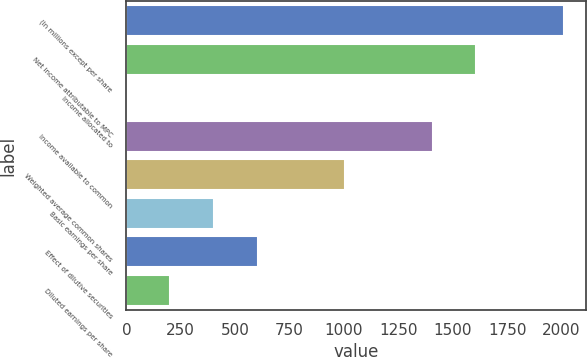<chart> <loc_0><loc_0><loc_500><loc_500><bar_chart><fcel>(In millions except per share<fcel>Net income attributable to MPC<fcel>Income allocated to<fcel>Income available to common<fcel>Weighted average common shares<fcel>Basic earnings per share<fcel>Effect of dilutive securities<fcel>Diluted earnings per share<nl><fcel>2010<fcel>1608.2<fcel>1<fcel>1407.3<fcel>1005.5<fcel>402.8<fcel>603.7<fcel>201.9<nl></chart> 